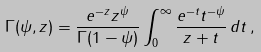<formula> <loc_0><loc_0><loc_500><loc_500>\Gamma ( \psi , z ) = \frac { e ^ { - z } z ^ { \psi } } { \Gamma ( 1 - \psi ) } \int _ { 0 } ^ { \infty } \frac { e ^ { - t } t ^ { - \psi } } { z + t } \, d t \, ,</formula> 